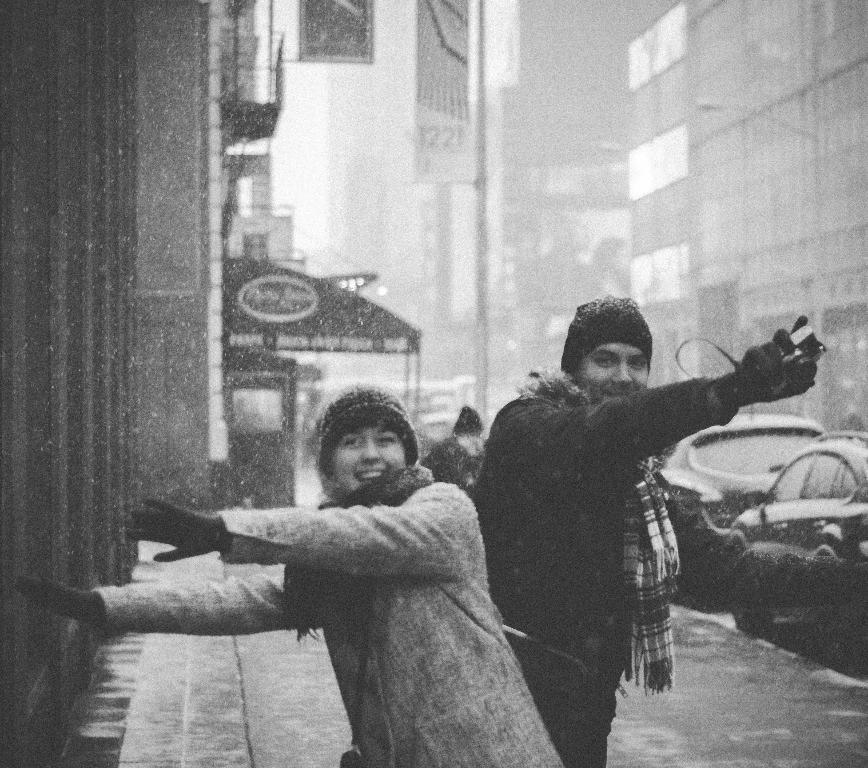Could you give a brief overview of what you see in this image? Black and white picture. This person is holding an object, wore a scarf, jacket and gloves. This woman also wore a jacket, gloves, scarf and smiling. Background we can see vehicles, tent, hoardings and buildings.   